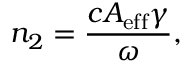Convert formula to latex. <formula><loc_0><loc_0><loc_500><loc_500>n _ { 2 } = \frac { c A _ { e f f } \gamma } { \omega } ,</formula> 